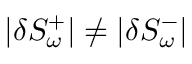<formula> <loc_0><loc_0><loc_500><loc_500>| \delta S _ { \omega } ^ { + } | \neq | \delta S _ { \omega } ^ { - } |</formula> 